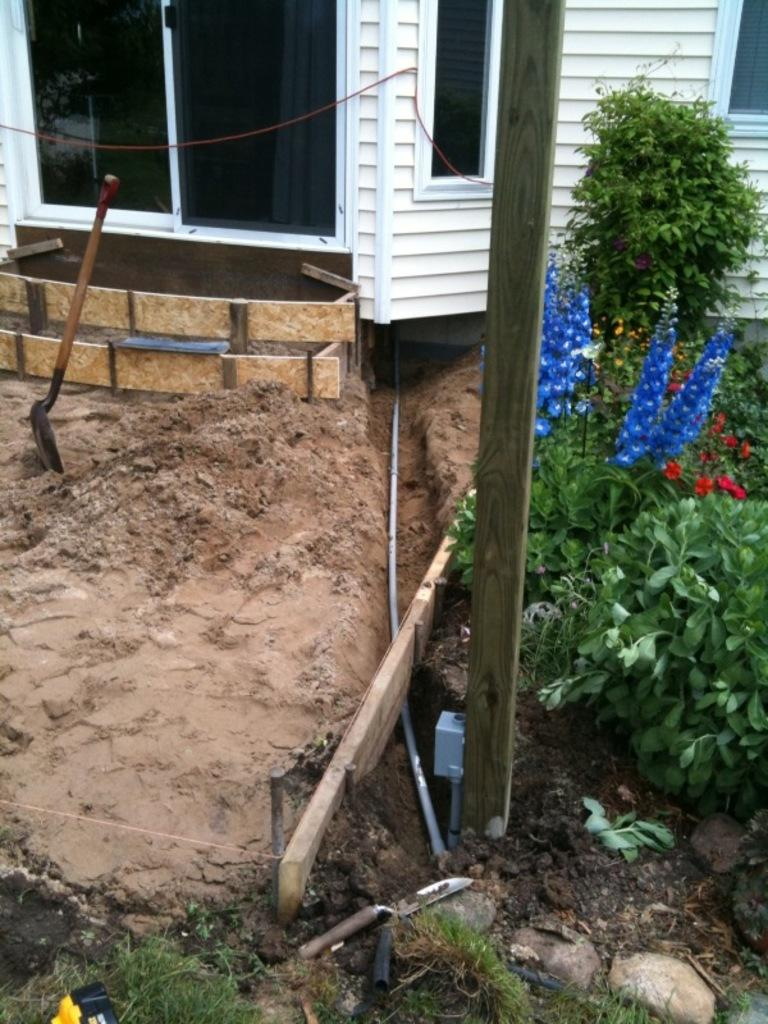What type of plants are visible in the image? There are plants with flowers in the image. What can be seen in the image besides the plants? There is a pipe, a digging tool, objects, sand, a wooden pole, a wall, windows, and glasses visible in the image. Where is the sink located in the image? There is no sink present in the image. Can you describe the tent in the image? There is no tent present in the image. 